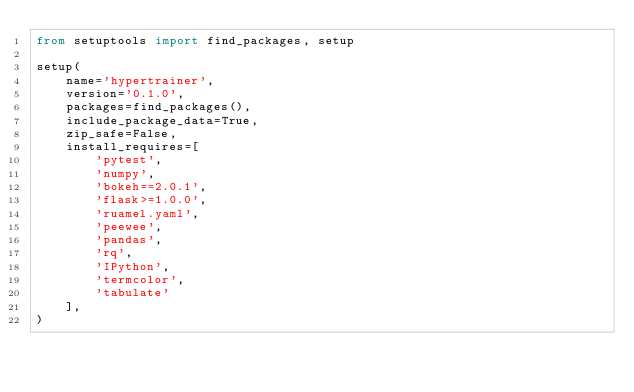Convert code to text. <code><loc_0><loc_0><loc_500><loc_500><_Python_>from setuptools import find_packages, setup

setup(
    name='hypertrainer',
    version='0.1.0',
    packages=find_packages(),
    include_package_data=True,
    zip_safe=False,
    install_requires=[
        'pytest',
        'numpy',
        'bokeh==2.0.1',
        'flask>=1.0.0',
        'ruamel.yaml',
        'peewee',
        'pandas',
        'rq',
        'IPython',
        'termcolor',
        'tabulate'
    ],
)
</code> 